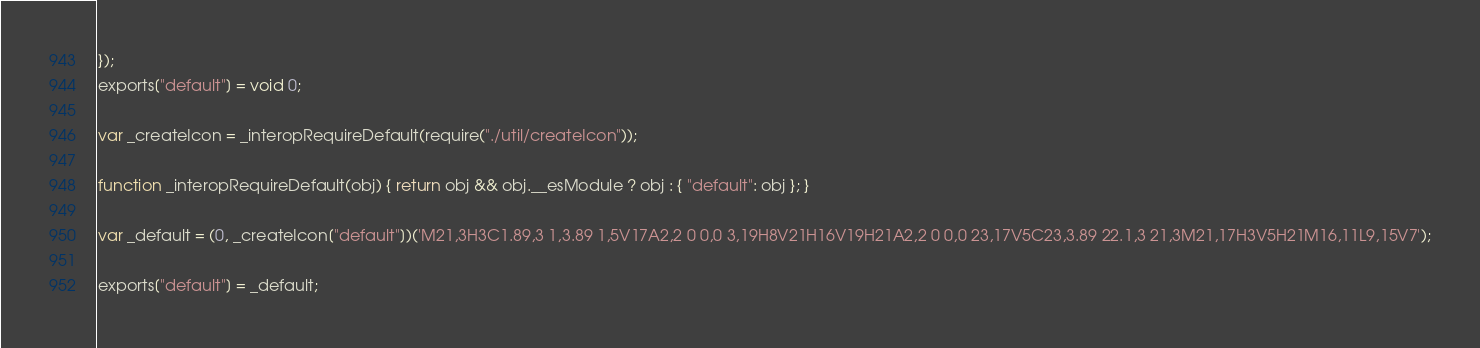Convert code to text. <code><loc_0><loc_0><loc_500><loc_500><_JavaScript_>});
exports["default"] = void 0;

var _createIcon = _interopRequireDefault(require("./util/createIcon"));

function _interopRequireDefault(obj) { return obj && obj.__esModule ? obj : { "default": obj }; }

var _default = (0, _createIcon["default"])('M21,3H3C1.89,3 1,3.89 1,5V17A2,2 0 0,0 3,19H8V21H16V19H21A2,2 0 0,0 23,17V5C23,3.89 22.1,3 21,3M21,17H3V5H21M16,11L9,15V7');

exports["default"] = _default;</code> 